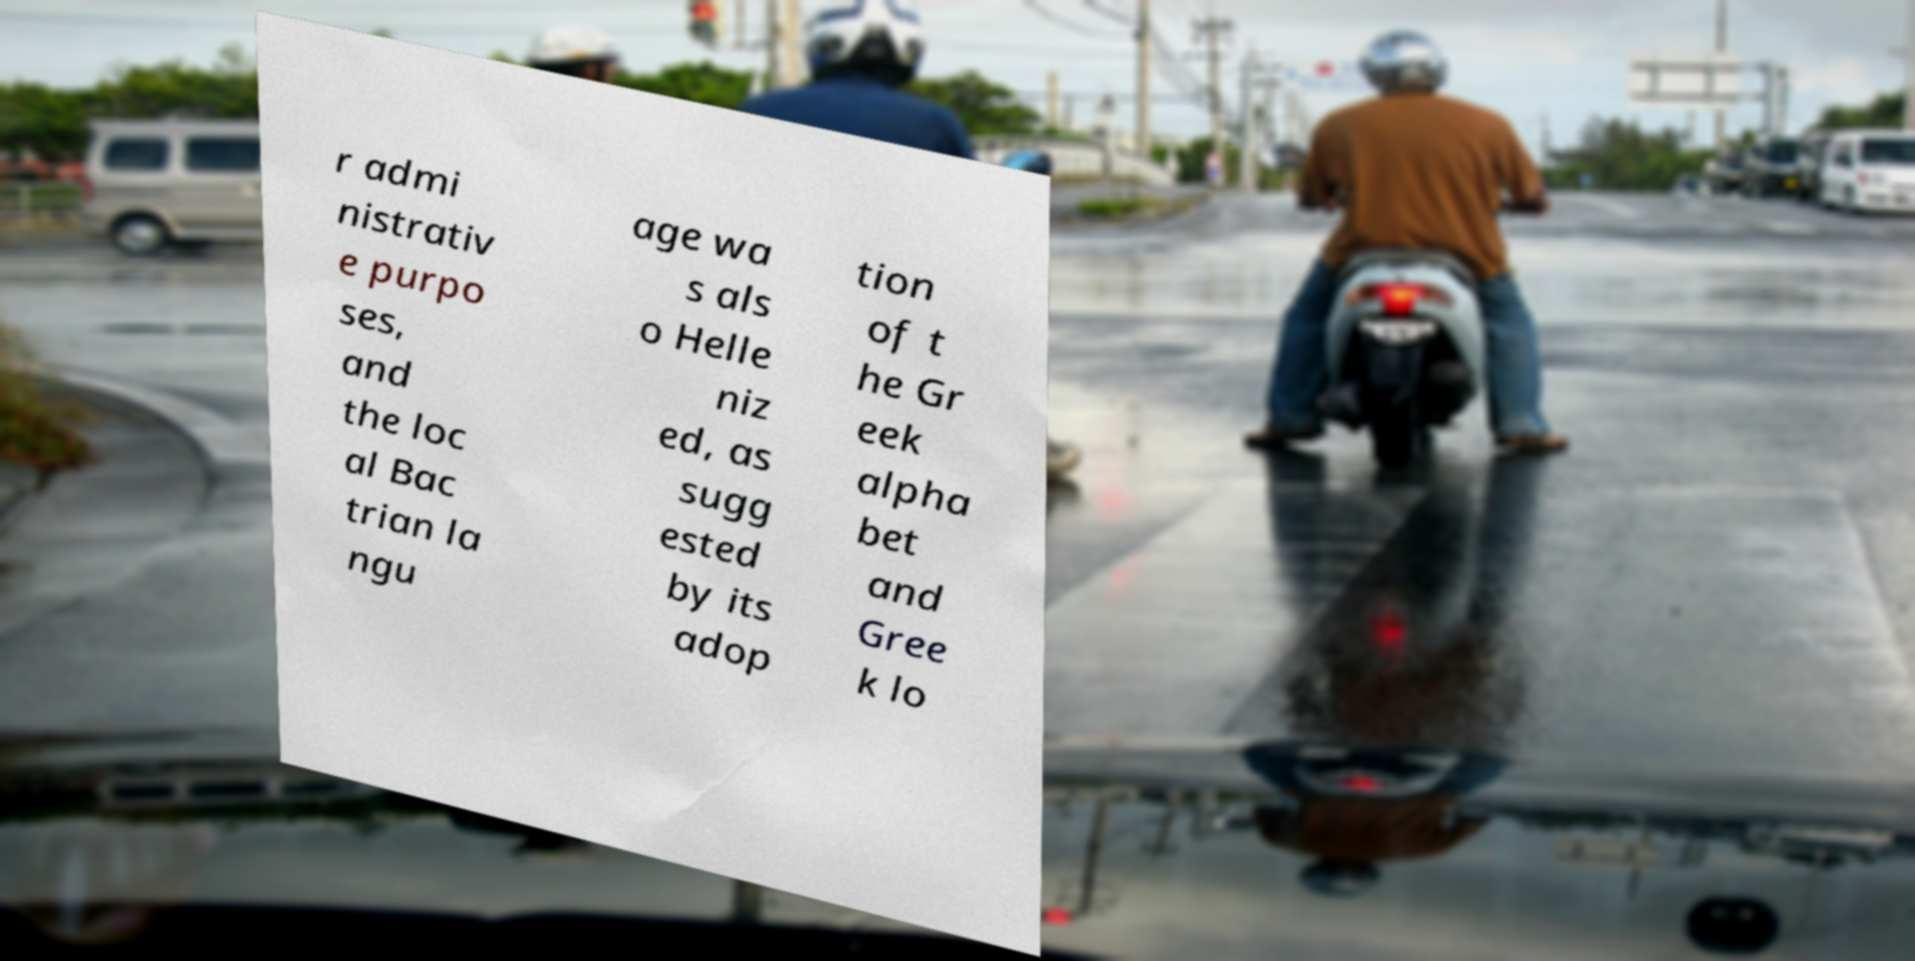Could you extract and type out the text from this image? r admi nistrativ e purpo ses, and the loc al Bac trian la ngu age wa s als o Helle niz ed, as sugg ested by its adop tion of t he Gr eek alpha bet and Gree k lo 